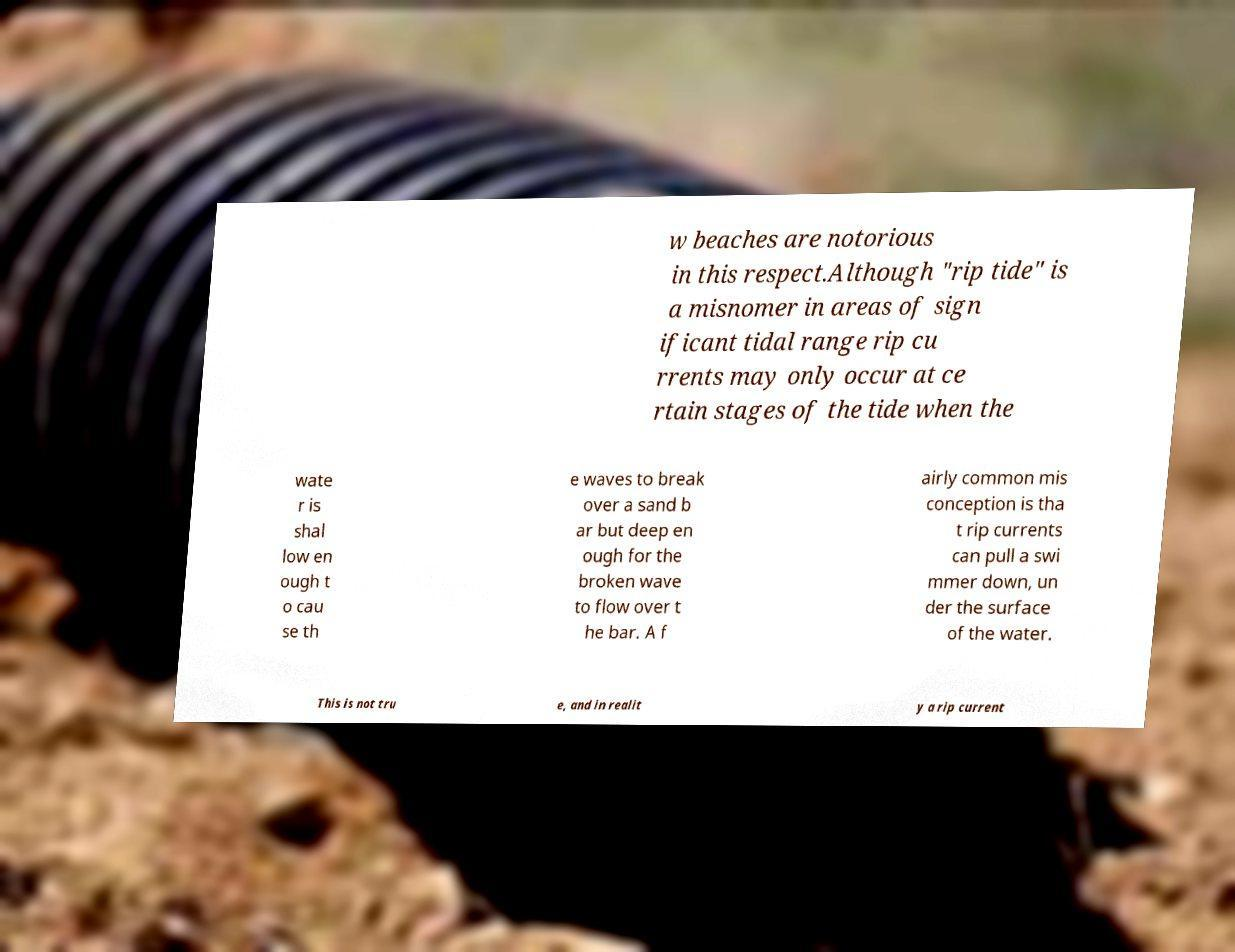Can you read and provide the text displayed in the image?This photo seems to have some interesting text. Can you extract and type it out for me? w beaches are notorious in this respect.Although "rip tide" is a misnomer in areas of sign ificant tidal range rip cu rrents may only occur at ce rtain stages of the tide when the wate r is shal low en ough t o cau se th e waves to break over a sand b ar but deep en ough for the broken wave to flow over t he bar. A f airly common mis conception is tha t rip currents can pull a swi mmer down, un der the surface of the water. This is not tru e, and in realit y a rip current 